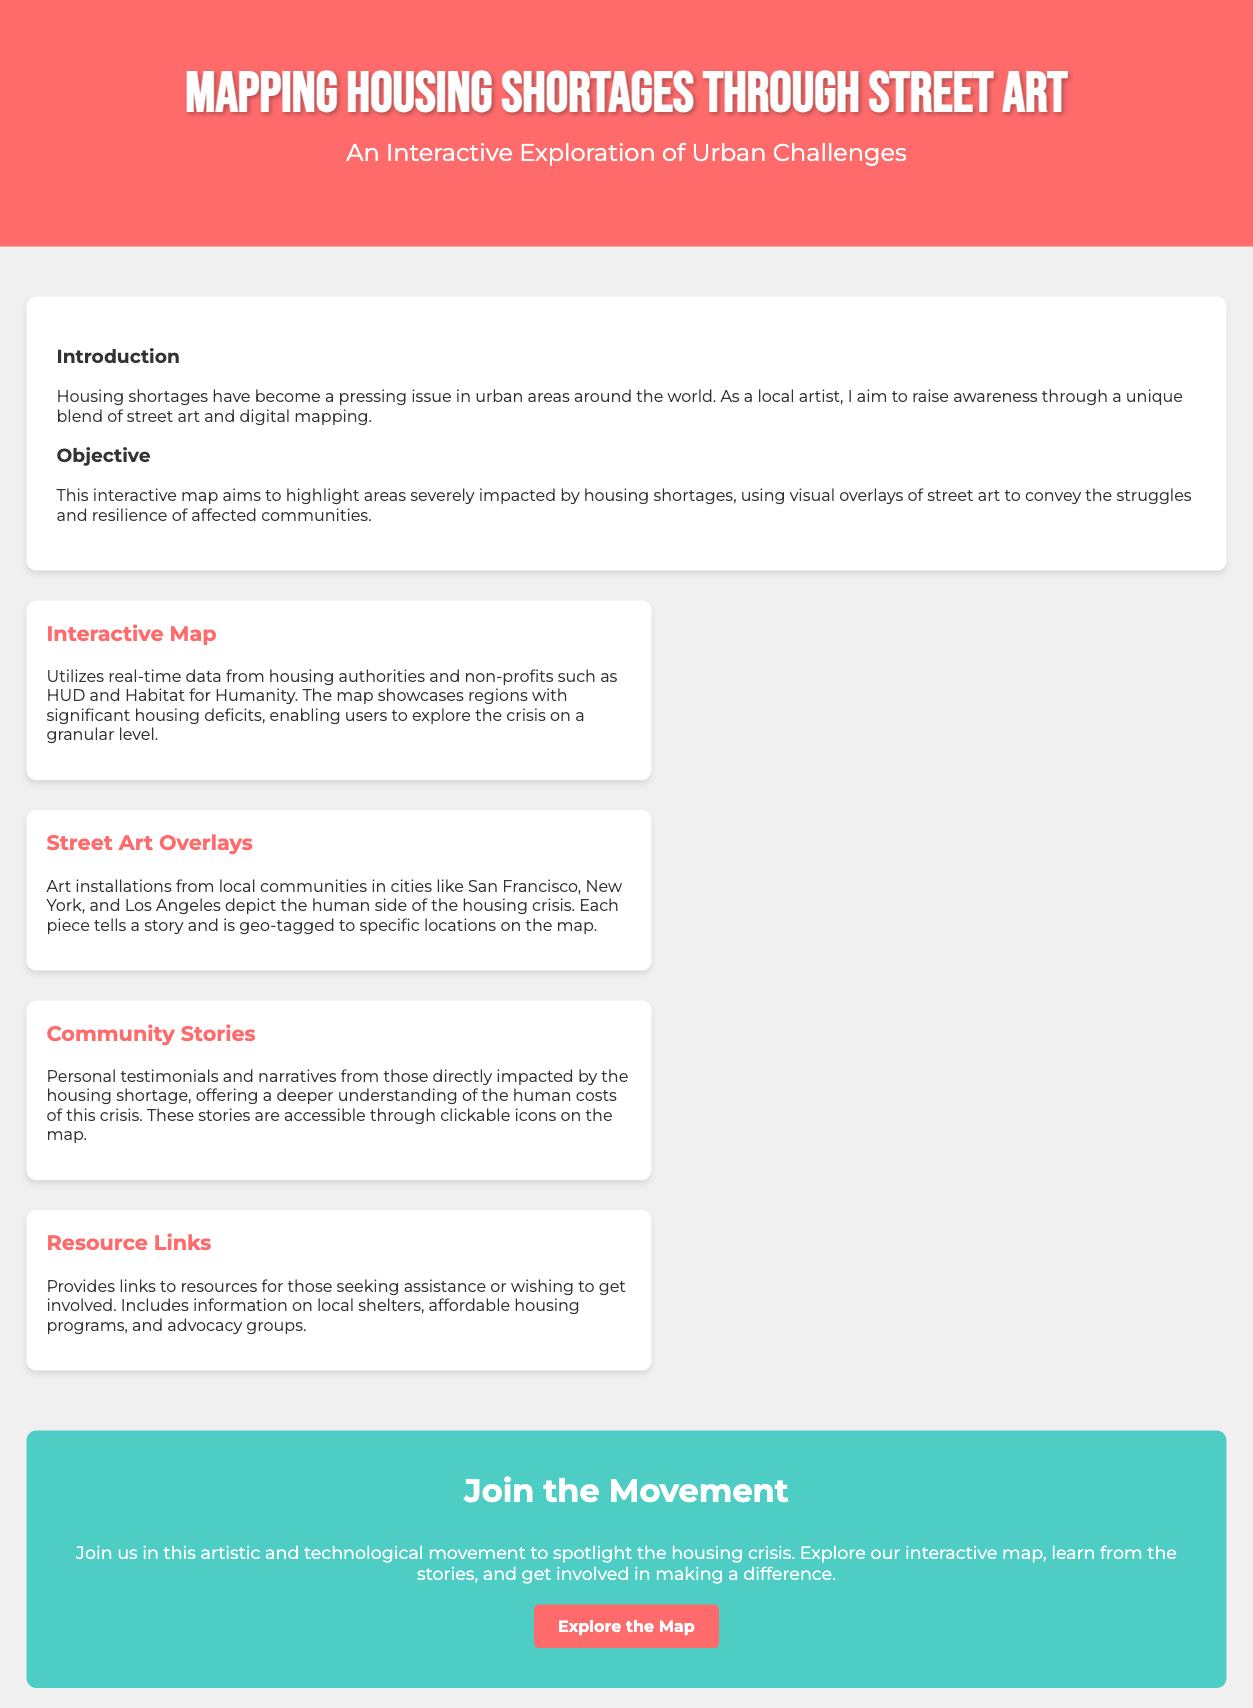what is the title of the document? The title is explicitly stated in the header section of the document.
Answer: Mapping Housing Shortages Through Street Art what is the main objective of the interactive map? The objective is described in a dedicated section that summarizes its purpose.
Answer: Highlight areas severely impacted by housing shortages which cities are mentioned for street art installations? The cities are specifically listed in the features section regarding street art.
Answer: San Francisco, New York, Los Angeles how many features are highlighted in the document? The features section provides a specific count of the individual features listed.
Answer: Four what color is used for the call-to-action section? The background color of the call-to-action section is described in the style section.
Answer: #4ecdc4 what story types are included in the map? The types of stories included are explicitly listed in the features section.
Answer: Community stories where can users find resource links? The resource links are mentioned in the features section concerning support and involvement.
Answer: Resource Links what can users do on the interactive map? The document outlines some specific actions available to users via the map.
Answer: Explore the crisis on a granular level 